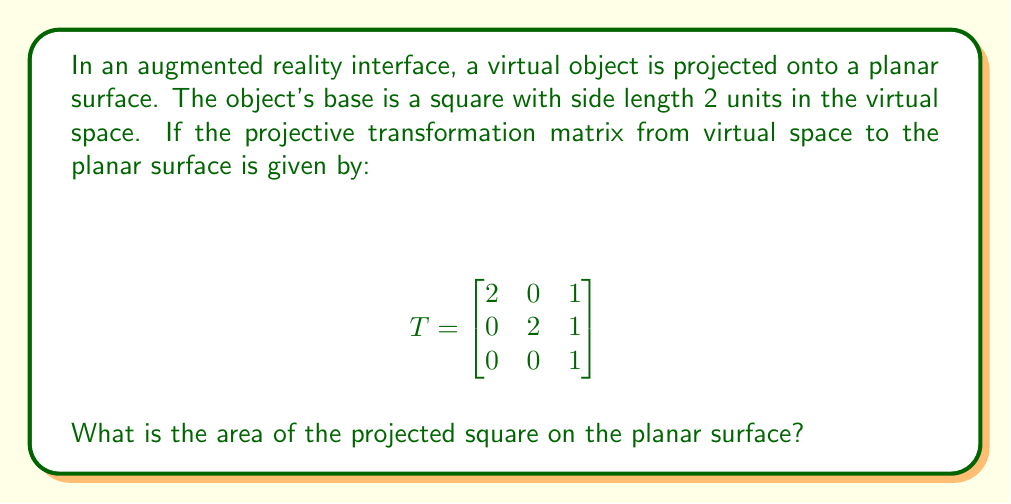Provide a solution to this math problem. Let's approach this step-by-step:

1) In projective geometry, points are represented in homogeneous coordinates. The corners of the square in virtual space are:
   $$(0,0,1), (2,0,1), (2,2,1), (0,2,1)$$

2) To transform these points, we multiply each by the transformation matrix:

   For $(0,0,1)$:
   $$ \begin{bmatrix} 2 & 0 & 1 \\ 0 & 2 & 1 \\ 0 & 0 & 1 \end{bmatrix} \begin{bmatrix} 0 \\ 0 \\ 1 \end{bmatrix} = \begin{bmatrix} 1 \\ 1 \\ 1 \end{bmatrix} $$

   For $(2,0,1)$:
   $$ \begin{bmatrix} 2 & 0 & 1 \\ 0 & 2 & 1 \\ 0 & 0 & 1 \end{bmatrix} \begin{bmatrix} 2 \\ 0 \\ 1 \end{bmatrix} = \begin{bmatrix} 5 \\ 1 \\ 1 \end{bmatrix} $$

   For $(2,2,1)$:
   $$ \begin{bmatrix} 2 & 0 & 1 \\ 0 & 2 & 1 \\ 0 & 0 & 1 \end{bmatrix} \begin{bmatrix} 2 \\ 2 \\ 1 \end{bmatrix} = \begin{bmatrix} 5 \\ 5 \\ 1 \end{bmatrix} $$

   For $(0,2,1)$:
   $$ \begin{bmatrix} 2 & 0 & 1 \\ 0 & 2 & 1 \\ 0 & 0 & 1 \end{bmatrix} \begin{bmatrix} 0 \\ 2 \\ 1 \end{bmatrix} = \begin{bmatrix} 1 \\ 5 \\ 1 \end{bmatrix} $$

3) To get Euclidean coordinates, we divide by the last component (which is 1 in all cases):
   $$(1,1), (5,1), (5,5), (1,5)$$

4) The projected square is actually a trapezoid. To calculate its area, we can split it into a rectangle and two triangles:

   [asy]
   unitsize(0.5cm);
   draw((1,1)--(5,1)--(5,5)--(1,5)--cycle);
   draw((1,1)--(5,5));
   label("A", (3,3), NE);
   label("B", (1,3), W);
   label("C", (5,3), E);
   [/asy]

5) Area of rectangle: $4 * 4 = 16$
   Area of triangle B: $\frac{1}{2} * 2 * 4 = 4$
   Area of triangle C: $\frac{1}{2} * 2 * 4 = 4$

6) Total area: $16 + 4 + 4 = 24$

Therefore, the area of the projected square on the planar surface is 24 square units.
Answer: 24 square units 